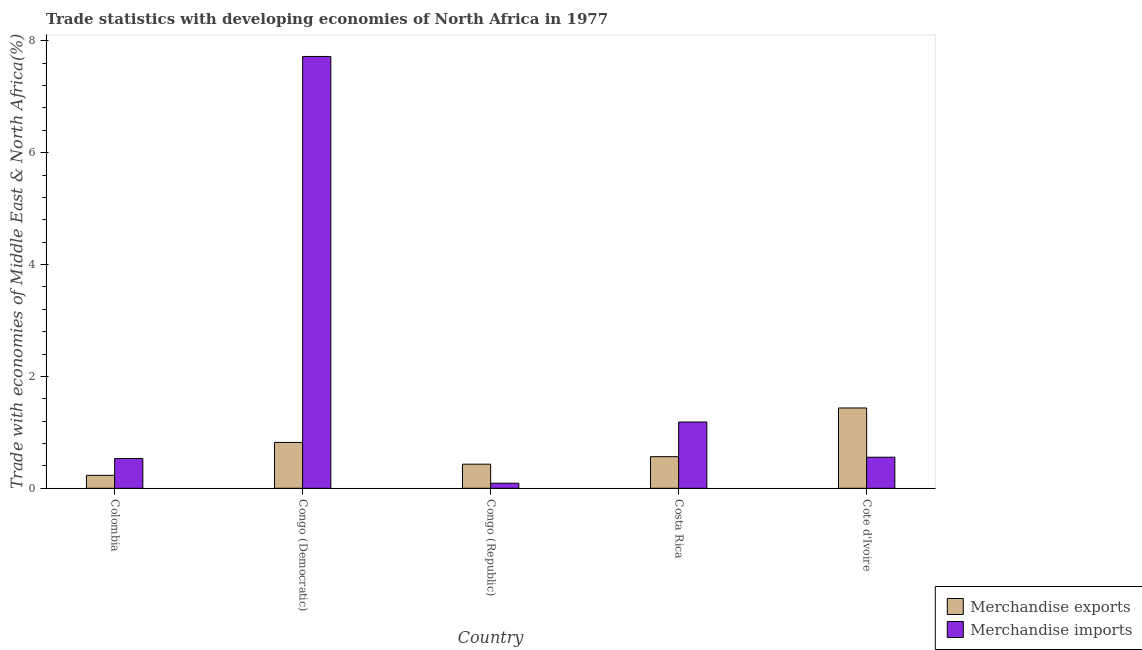How many different coloured bars are there?
Ensure brevity in your answer.  2. How many bars are there on the 2nd tick from the left?
Make the answer very short. 2. How many bars are there on the 4th tick from the right?
Provide a short and direct response. 2. What is the label of the 4th group of bars from the left?
Offer a terse response. Costa Rica. In how many cases, is the number of bars for a given country not equal to the number of legend labels?
Keep it short and to the point. 0. What is the merchandise imports in Congo (Democratic)?
Give a very brief answer. 7.72. Across all countries, what is the maximum merchandise imports?
Ensure brevity in your answer.  7.72. Across all countries, what is the minimum merchandise imports?
Keep it short and to the point. 0.09. In which country was the merchandise exports maximum?
Your answer should be very brief. Cote d'Ivoire. What is the total merchandise exports in the graph?
Keep it short and to the point. 3.48. What is the difference between the merchandise exports in Colombia and that in Cote d'Ivoire?
Offer a terse response. -1.2. What is the difference between the merchandise exports in Colombia and the merchandise imports in Congo (Democratic)?
Offer a very short reply. -7.49. What is the average merchandise exports per country?
Make the answer very short. 0.7. What is the difference between the merchandise exports and merchandise imports in Cote d'Ivoire?
Offer a very short reply. 0.88. What is the ratio of the merchandise imports in Congo (Democratic) to that in Cote d'Ivoire?
Keep it short and to the point. 13.89. Is the merchandise exports in Colombia less than that in Cote d'Ivoire?
Offer a terse response. Yes. Is the difference between the merchandise exports in Congo (Democratic) and Costa Rica greater than the difference between the merchandise imports in Congo (Democratic) and Costa Rica?
Your answer should be very brief. No. What is the difference between the highest and the second highest merchandise exports?
Make the answer very short. 0.62. What is the difference between the highest and the lowest merchandise exports?
Your answer should be very brief. 1.2. In how many countries, is the merchandise exports greater than the average merchandise exports taken over all countries?
Provide a short and direct response. 2. Is the sum of the merchandise imports in Colombia and Congo (Democratic) greater than the maximum merchandise exports across all countries?
Offer a very short reply. Yes. What does the 2nd bar from the left in Costa Rica represents?
Ensure brevity in your answer.  Merchandise imports. Are all the bars in the graph horizontal?
Your response must be concise. No. How many countries are there in the graph?
Keep it short and to the point. 5. What is the difference between two consecutive major ticks on the Y-axis?
Ensure brevity in your answer.  2. Are the values on the major ticks of Y-axis written in scientific E-notation?
Your answer should be very brief. No. Does the graph contain any zero values?
Keep it short and to the point. No. Does the graph contain grids?
Your answer should be very brief. No. Where does the legend appear in the graph?
Your answer should be very brief. Bottom right. How are the legend labels stacked?
Offer a very short reply. Vertical. What is the title of the graph?
Ensure brevity in your answer.  Trade statistics with developing economies of North Africa in 1977. What is the label or title of the X-axis?
Give a very brief answer. Country. What is the label or title of the Y-axis?
Ensure brevity in your answer.  Trade with economies of Middle East & North Africa(%). What is the Trade with economies of Middle East & North Africa(%) in Merchandise exports in Colombia?
Your answer should be very brief. 0.23. What is the Trade with economies of Middle East & North Africa(%) in Merchandise imports in Colombia?
Ensure brevity in your answer.  0.53. What is the Trade with economies of Middle East & North Africa(%) in Merchandise exports in Congo (Democratic)?
Offer a very short reply. 0.82. What is the Trade with economies of Middle East & North Africa(%) of Merchandise imports in Congo (Democratic)?
Your answer should be very brief. 7.72. What is the Trade with economies of Middle East & North Africa(%) of Merchandise exports in Congo (Republic)?
Ensure brevity in your answer.  0.43. What is the Trade with economies of Middle East & North Africa(%) of Merchandise imports in Congo (Republic)?
Make the answer very short. 0.09. What is the Trade with economies of Middle East & North Africa(%) of Merchandise exports in Costa Rica?
Your answer should be compact. 0.57. What is the Trade with economies of Middle East & North Africa(%) in Merchandise imports in Costa Rica?
Provide a short and direct response. 1.19. What is the Trade with economies of Middle East & North Africa(%) of Merchandise exports in Cote d'Ivoire?
Your response must be concise. 1.44. What is the Trade with economies of Middle East & North Africa(%) of Merchandise imports in Cote d'Ivoire?
Keep it short and to the point. 0.56. Across all countries, what is the maximum Trade with economies of Middle East & North Africa(%) of Merchandise exports?
Your answer should be compact. 1.44. Across all countries, what is the maximum Trade with economies of Middle East & North Africa(%) in Merchandise imports?
Ensure brevity in your answer.  7.72. Across all countries, what is the minimum Trade with economies of Middle East & North Africa(%) in Merchandise exports?
Offer a very short reply. 0.23. Across all countries, what is the minimum Trade with economies of Middle East & North Africa(%) in Merchandise imports?
Offer a very short reply. 0.09. What is the total Trade with economies of Middle East & North Africa(%) in Merchandise exports in the graph?
Provide a succinct answer. 3.48. What is the total Trade with economies of Middle East & North Africa(%) in Merchandise imports in the graph?
Ensure brevity in your answer.  10.08. What is the difference between the Trade with economies of Middle East & North Africa(%) of Merchandise exports in Colombia and that in Congo (Democratic)?
Your answer should be compact. -0.59. What is the difference between the Trade with economies of Middle East & North Africa(%) of Merchandise imports in Colombia and that in Congo (Democratic)?
Give a very brief answer. -7.19. What is the difference between the Trade with economies of Middle East & North Africa(%) of Merchandise exports in Colombia and that in Congo (Republic)?
Offer a terse response. -0.2. What is the difference between the Trade with economies of Middle East & North Africa(%) in Merchandise imports in Colombia and that in Congo (Republic)?
Ensure brevity in your answer.  0.44. What is the difference between the Trade with economies of Middle East & North Africa(%) of Merchandise exports in Colombia and that in Costa Rica?
Offer a very short reply. -0.33. What is the difference between the Trade with economies of Middle East & North Africa(%) of Merchandise imports in Colombia and that in Costa Rica?
Give a very brief answer. -0.65. What is the difference between the Trade with economies of Middle East & North Africa(%) of Merchandise exports in Colombia and that in Cote d'Ivoire?
Provide a succinct answer. -1.2. What is the difference between the Trade with economies of Middle East & North Africa(%) of Merchandise imports in Colombia and that in Cote d'Ivoire?
Make the answer very short. -0.02. What is the difference between the Trade with economies of Middle East & North Africa(%) of Merchandise exports in Congo (Democratic) and that in Congo (Republic)?
Keep it short and to the point. 0.39. What is the difference between the Trade with economies of Middle East & North Africa(%) of Merchandise imports in Congo (Democratic) and that in Congo (Republic)?
Your response must be concise. 7.63. What is the difference between the Trade with economies of Middle East & North Africa(%) in Merchandise exports in Congo (Democratic) and that in Costa Rica?
Ensure brevity in your answer.  0.25. What is the difference between the Trade with economies of Middle East & North Africa(%) in Merchandise imports in Congo (Democratic) and that in Costa Rica?
Provide a succinct answer. 6.54. What is the difference between the Trade with economies of Middle East & North Africa(%) of Merchandise exports in Congo (Democratic) and that in Cote d'Ivoire?
Your response must be concise. -0.62. What is the difference between the Trade with economies of Middle East & North Africa(%) in Merchandise imports in Congo (Democratic) and that in Cote d'Ivoire?
Ensure brevity in your answer.  7.17. What is the difference between the Trade with economies of Middle East & North Africa(%) of Merchandise exports in Congo (Republic) and that in Costa Rica?
Ensure brevity in your answer.  -0.13. What is the difference between the Trade with economies of Middle East & North Africa(%) in Merchandise imports in Congo (Republic) and that in Costa Rica?
Keep it short and to the point. -1.1. What is the difference between the Trade with economies of Middle East & North Africa(%) of Merchandise exports in Congo (Republic) and that in Cote d'Ivoire?
Your response must be concise. -1.01. What is the difference between the Trade with economies of Middle East & North Africa(%) of Merchandise imports in Congo (Republic) and that in Cote d'Ivoire?
Your response must be concise. -0.47. What is the difference between the Trade with economies of Middle East & North Africa(%) in Merchandise exports in Costa Rica and that in Cote d'Ivoire?
Offer a very short reply. -0.87. What is the difference between the Trade with economies of Middle East & North Africa(%) of Merchandise imports in Costa Rica and that in Cote d'Ivoire?
Offer a terse response. 0.63. What is the difference between the Trade with economies of Middle East & North Africa(%) in Merchandise exports in Colombia and the Trade with economies of Middle East & North Africa(%) in Merchandise imports in Congo (Democratic)?
Ensure brevity in your answer.  -7.49. What is the difference between the Trade with economies of Middle East & North Africa(%) in Merchandise exports in Colombia and the Trade with economies of Middle East & North Africa(%) in Merchandise imports in Congo (Republic)?
Your answer should be very brief. 0.14. What is the difference between the Trade with economies of Middle East & North Africa(%) of Merchandise exports in Colombia and the Trade with economies of Middle East & North Africa(%) of Merchandise imports in Costa Rica?
Your response must be concise. -0.95. What is the difference between the Trade with economies of Middle East & North Africa(%) in Merchandise exports in Colombia and the Trade with economies of Middle East & North Africa(%) in Merchandise imports in Cote d'Ivoire?
Give a very brief answer. -0.32. What is the difference between the Trade with economies of Middle East & North Africa(%) in Merchandise exports in Congo (Democratic) and the Trade with economies of Middle East & North Africa(%) in Merchandise imports in Congo (Republic)?
Ensure brevity in your answer.  0.73. What is the difference between the Trade with economies of Middle East & North Africa(%) in Merchandise exports in Congo (Democratic) and the Trade with economies of Middle East & North Africa(%) in Merchandise imports in Costa Rica?
Your response must be concise. -0.37. What is the difference between the Trade with economies of Middle East & North Africa(%) of Merchandise exports in Congo (Democratic) and the Trade with economies of Middle East & North Africa(%) of Merchandise imports in Cote d'Ivoire?
Ensure brevity in your answer.  0.26. What is the difference between the Trade with economies of Middle East & North Africa(%) in Merchandise exports in Congo (Republic) and the Trade with economies of Middle East & North Africa(%) in Merchandise imports in Costa Rica?
Ensure brevity in your answer.  -0.75. What is the difference between the Trade with economies of Middle East & North Africa(%) in Merchandise exports in Congo (Republic) and the Trade with economies of Middle East & North Africa(%) in Merchandise imports in Cote d'Ivoire?
Your answer should be compact. -0.12. What is the difference between the Trade with economies of Middle East & North Africa(%) in Merchandise exports in Costa Rica and the Trade with economies of Middle East & North Africa(%) in Merchandise imports in Cote d'Ivoire?
Provide a short and direct response. 0.01. What is the average Trade with economies of Middle East & North Africa(%) in Merchandise exports per country?
Ensure brevity in your answer.  0.7. What is the average Trade with economies of Middle East & North Africa(%) in Merchandise imports per country?
Provide a short and direct response. 2.02. What is the difference between the Trade with economies of Middle East & North Africa(%) in Merchandise exports and Trade with economies of Middle East & North Africa(%) in Merchandise imports in Colombia?
Ensure brevity in your answer.  -0.3. What is the difference between the Trade with economies of Middle East & North Africa(%) in Merchandise exports and Trade with economies of Middle East & North Africa(%) in Merchandise imports in Congo (Democratic)?
Provide a succinct answer. -6.9. What is the difference between the Trade with economies of Middle East & North Africa(%) in Merchandise exports and Trade with economies of Middle East & North Africa(%) in Merchandise imports in Congo (Republic)?
Give a very brief answer. 0.34. What is the difference between the Trade with economies of Middle East & North Africa(%) of Merchandise exports and Trade with economies of Middle East & North Africa(%) of Merchandise imports in Costa Rica?
Ensure brevity in your answer.  -0.62. What is the difference between the Trade with economies of Middle East & North Africa(%) in Merchandise exports and Trade with economies of Middle East & North Africa(%) in Merchandise imports in Cote d'Ivoire?
Offer a very short reply. 0.88. What is the ratio of the Trade with economies of Middle East & North Africa(%) in Merchandise exports in Colombia to that in Congo (Democratic)?
Your answer should be very brief. 0.28. What is the ratio of the Trade with economies of Middle East & North Africa(%) in Merchandise imports in Colombia to that in Congo (Democratic)?
Your answer should be compact. 0.07. What is the ratio of the Trade with economies of Middle East & North Africa(%) of Merchandise exports in Colombia to that in Congo (Republic)?
Your answer should be compact. 0.54. What is the ratio of the Trade with economies of Middle East & North Africa(%) of Merchandise imports in Colombia to that in Congo (Republic)?
Your answer should be very brief. 5.9. What is the ratio of the Trade with economies of Middle East & North Africa(%) of Merchandise exports in Colombia to that in Costa Rica?
Provide a succinct answer. 0.41. What is the ratio of the Trade with economies of Middle East & North Africa(%) of Merchandise imports in Colombia to that in Costa Rica?
Offer a very short reply. 0.45. What is the ratio of the Trade with economies of Middle East & North Africa(%) of Merchandise exports in Colombia to that in Cote d'Ivoire?
Offer a very short reply. 0.16. What is the ratio of the Trade with economies of Middle East & North Africa(%) in Merchandise imports in Colombia to that in Cote d'Ivoire?
Ensure brevity in your answer.  0.96. What is the ratio of the Trade with economies of Middle East & North Africa(%) of Merchandise exports in Congo (Democratic) to that in Congo (Republic)?
Your answer should be very brief. 1.9. What is the ratio of the Trade with economies of Middle East & North Africa(%) in Merchandise imports in Congo (Democratic) to that in Congo (Republic)?
Provide a short and direct response. 85.56. What is the ratio of the Trade with economies of Middle East & North Africa(%) of Merchandise exports in Congo (Democratic) to that in Costa Rica?
Ensure brevity in your answer.  1.45. What is the ratio of the Trade with economies of Middle East & North Africa(%) in Merchandise imports in Congo (Democratic) to that in Costa Rica?
Your response must be concise. 6.51. What is the ratio of the Trade with economies of Middle East & North Africa(%) in Merchandise exports in Congo (Democratic) to that in Cote d'Ivoire?
Your answer should be very brief. 0.57. What is the ratio of the Trade with economies of Middle East & North Africa(%) in Merchandise imports in Congo (Democratic) to that in Cote d'Ivoire?
Ensure brevity in your answer.  13.89. What is the ratio of the Trade with economies of Middle East & North Africa(%) in Merchandise exports in Congo (Republic) to that in Costa Rica?
Ensure brevity in your answer.  0.76. What is the ratio of the Trade with economies of Middle East & North Africa(%) of Merchandise imports in Congo (Republic) to that in Costa Rica?
Provide a short and direct response. 0.08. What is the ratio of the Trade with economies of Middle East & North Africa(%) in Merchandise exports in Congo (Republic) to that in Cote d'Ivoire?
Your answer should be compact. 0.3. What is the ratio of the Trade with economies of Middle East & North Africa(%) of Merchandise imports in Congo (Republic) to that in Cote d'Ivoire?
Give a very brief answer. 0.16. What is the ratio of the Trade with economies of Middle East & North Africa(%) of Merchandise exports in Costa Rica to that in Cote d'Ivoire?
Ensure brevity in your answer.  0.39. What is the ratio of the Trade with economies of Middle East & North Africa(%) of Merchandise imports in Costa Rica to that in Cote d'Ivoire?
Offer a very short reply. 2.13. What is the difference between the highest and the second highest Trade with economies of Middle East & North Africa(%) in Merchandise exports?
Keep it short and to the point. 0.62. What is the difference between the highest and the second highest Trade with economies of Middle East & North Africa(%) of Merchandise imports?
Keep it short and to the point. 6.54. What is the difference between the highest and the lowest Trade with economies of Middle East & North Africa(%) of Merchandise exports?
Keep it short and to the point. 1.2. What is the difference between the highest and the lowest Trade with economies of Middle East & North Africa(%) in Merchandise imports?
Offer a terse response. 7.63. 